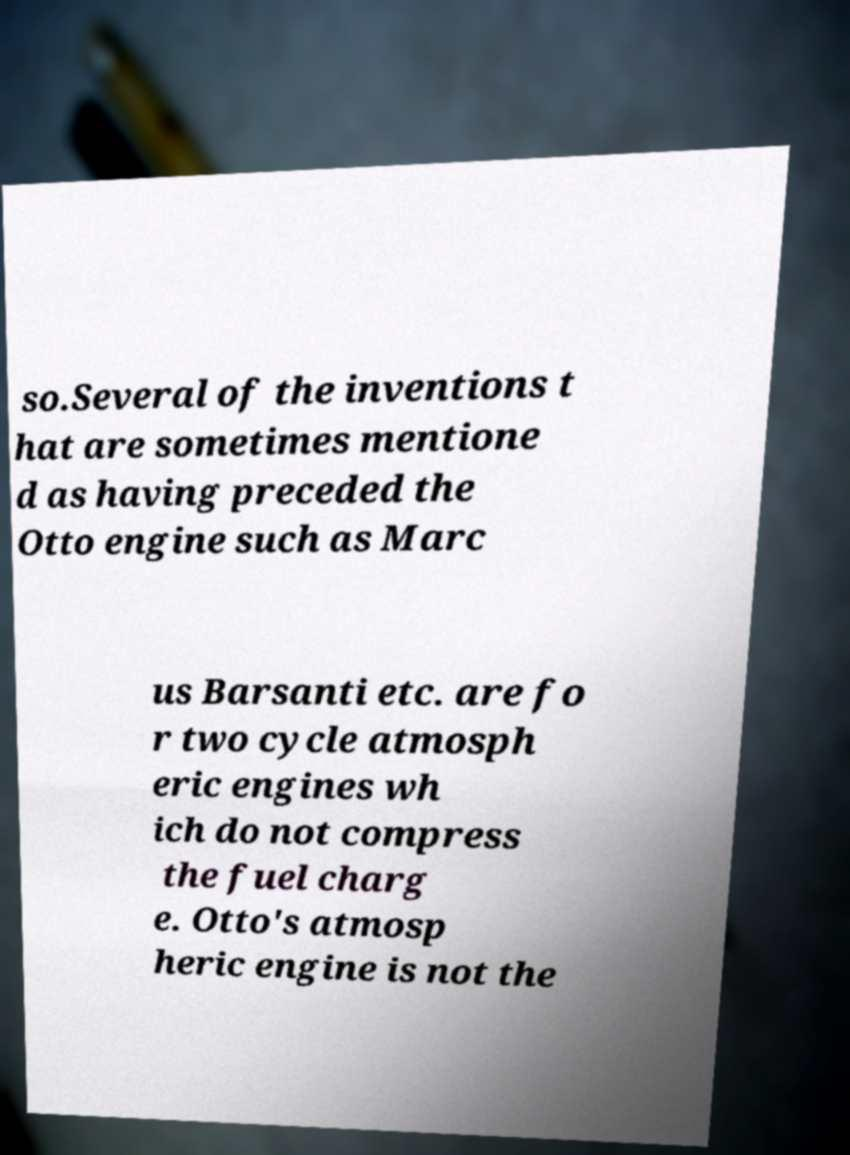I need the written content from this picture converted into text. Can you do that? so.Several of the inventions t hat are sometimes mentione d as having preceded the Otto engine such as Marc us Barsanti etc. are fo r two cycle atmosph eric engines wh ich do not compress the fuel charg e. Otto's atmosp heric engine is not the 